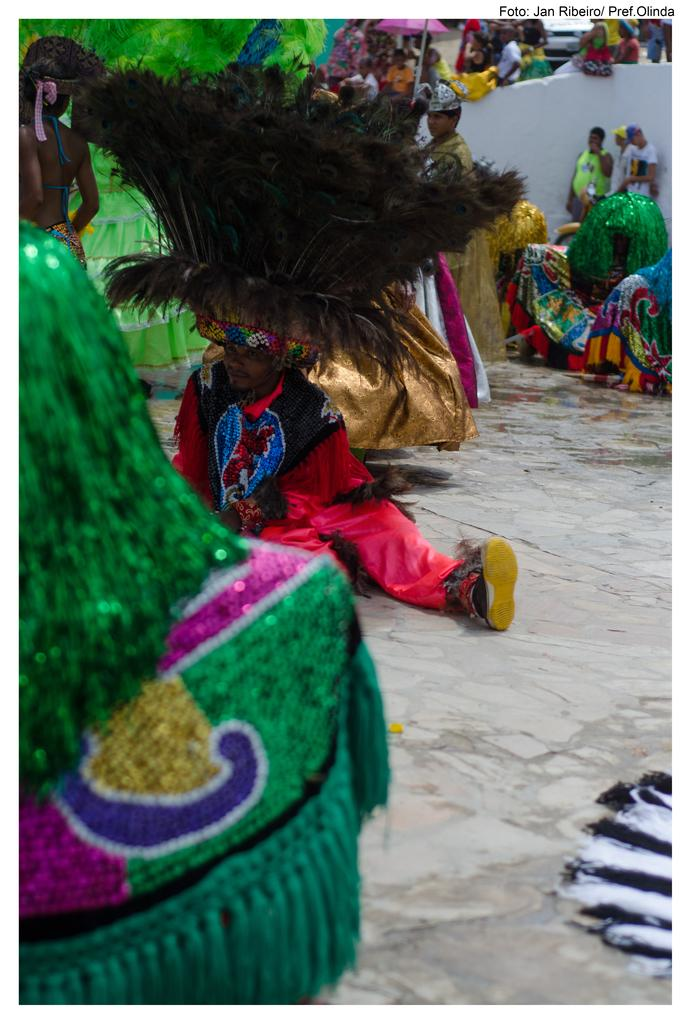What is the general setting of the image? There is a group of people in the image. What are the people wearing? The people are in fancy dress. How are the people positioned in the image? Some people are sitting, while others are standing. Where are the people located? They are on a path. Is there any additional information about the image? There is a watermark on the image. What type of horn can be seen in the image? There is no horn present in the image. 